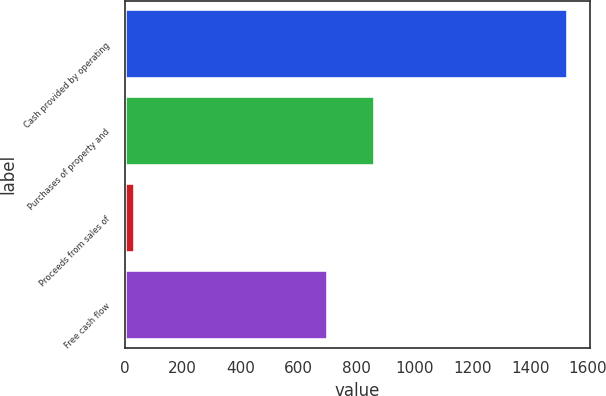Convert chart. <chart><loc_0><loc_0><loc_500><loc_500><bar_chart><fcel>Cash provided by operating<fcel>Purchases of property and<fcel>Proceeds from sales of<fcel>Free cash flow<nl><fcel>1529.8<fcel>862.5<fcel>35.7<fcel>703<nl></chart> 